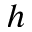Convert formula to latex. <formula><loc_0><loc_0><loc_500><loc_500>h</formula> 